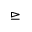<formula> <loc_0><loc_0><loc_500><loc_500>\triangleright e q</formula> 